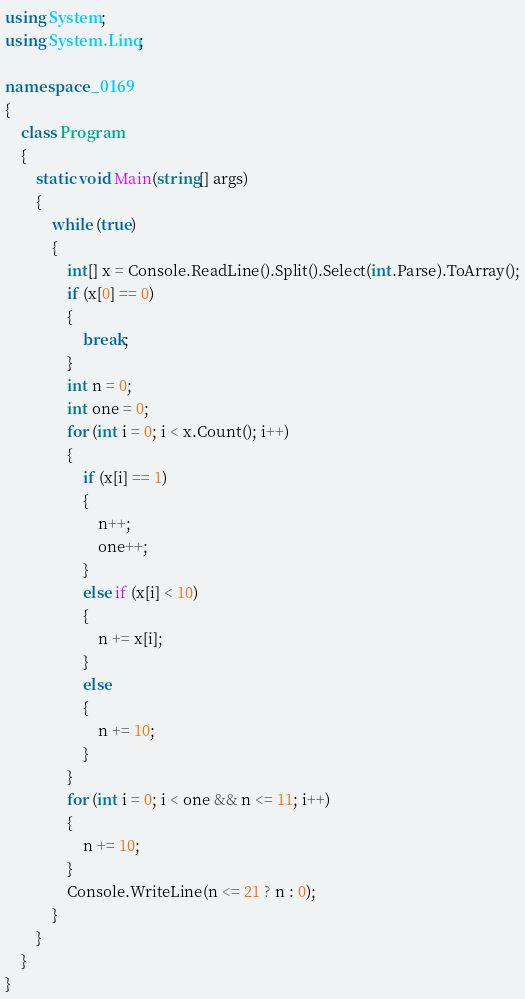<code> <loc_0><loc_0><loc_500><loc_500><_C#_>using System;
using System.Linq;

namespace _0169
{
    class Program
    {
        static void Main(string[] args)
        {
            while (true)
            {
                int[] x = Console.ReadLine().Split().Select(int.Parse).ToArray();
                if (x[0] == 0)
                {
                    break;
                }
                int n = 0;
                int one = 0;
                for (int i = 0; i < x.Count(); i++)
                {
                    if (x[i] == 1)
                    {
                        n++;
                        one++;
                    }
                    else if (x[i] < 10)
                    {
                        n += x[i];
                    }
                    else
                    {
                        n += 10;
                    }
                }
                for (int i = 0; i < one && n <= 11; i++)
                {
                    n += 10;
                }
                Console.WriteLine(n <= 21 ? n : 0);
            }
        }
    }
}</code> 